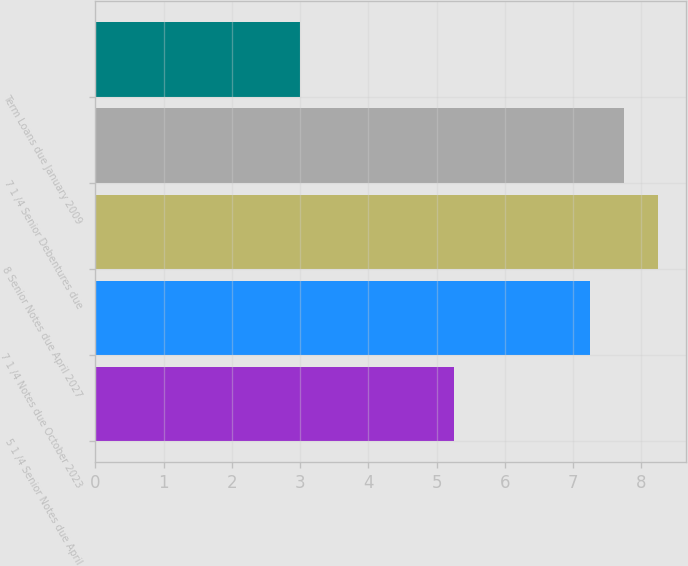Convert chart. <chart><loc_0><loc_0><loc_500><loc_500><bar_chart><fcel>5 1 /4 Senior Notes due April<fcel>7 1 /4 Notes due October 2023<fcel>8 Senior Notes due April 2027<fcel>7 1 /4 Senior Debentures due<fcel>Term Loans due January 2009<nl><fcel>5.25<fcel>7.25<fcel>8.25<fcel>7.75<fcel>3<nl></chart> 